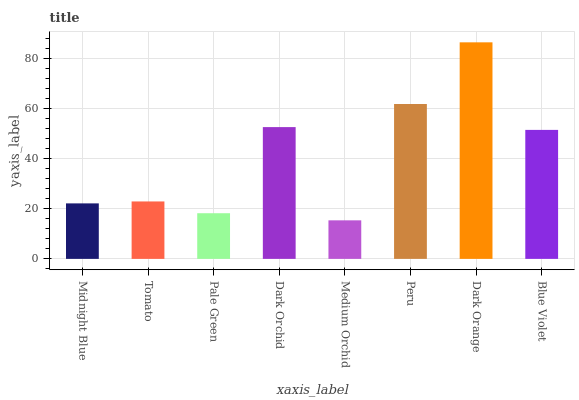Is Tomato the minimum?
Answer yes or no. No. Is Tomato the maximum?
Answer yes or no. No. Is Tomato greater than Midnight Blue?
Answer yes or no. Yes. Is Midnight Blue less than Tomato?
Answer yes or no. Yes. Is Midnight Blue greater than Tomato?
Answer yes or no. No. Is Tomato less than Midnight Blue?
Answer yes or no. No. Is Blue Violet the high median?
Answer yes or no. Yes. Is Tomato the low median?
Answer yes or no. Yes. Is Dark Orchid the high median?
Answer yes or no. No. Is Peru the low median?
Answer yes or no. No. 